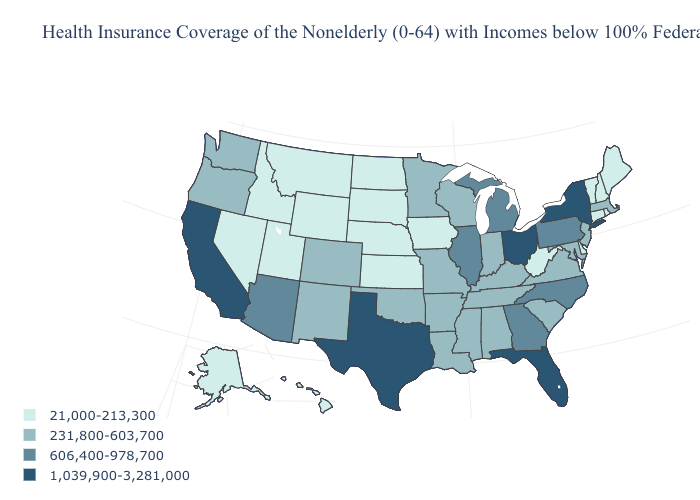Which states have the highest value in the USA?
Write a very short answer. California, Florida, New York, Ohio, Texas. What is the value of Florida?
Give a very brief answer. 1,039,900-3,281,000. What is the highest value in the South ?
Give a very brief answer. 1,039,900-3,281,000. Among the states that border Arizona , does California have the highest value?
Quick response, please. Yes. Name the states that have a value in the range 1,039,900-3,281,000?
Write a very short answer. California, Florida, New York, Ohio, Texas. How many symbols are there in the legend?
Concise answer only. 4. What is the value of Utah?
Keep it brief. 21,000-213,300. Does New Jersey have the lowest value in the Northeast?
Give a very brief answer. No. Is the legend a continuous bar?
Be succinct. No. How many symbols are there in the legend?
Keep it brief. 4. Name the states that have a value in the range 231,800-603,700?
Quick response, please. Alabama, Arkansas, Colorado, Indiana, Kentucky, Louisiana, Maryland, Massachusetts, Minnesota, Mississippi, Missouri, New Jersey, New Mexico, Oklahoma, Oregon, South Carolina, Tennessee, Virginia, Washington, Wisconsin. What is the lowest value in the South?
Answer briefly. 21,000-213,300. What is the value of Alaska?
Be succinct. 21,000-213,300. What is the value of Rhode Island?
Quick response, please. 21,000-213,300. Which states hav the highest value in the MidWest?
Concise answer only. Ohio. 